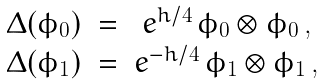Convert formula to latex. <formula><loc_0><loc_0><loc_500><loc_500>\begin{array} { c c c } \Delta ( \phi _ { 0 } ) & = & e ^ { h / 4 } \, \phi _ { 0 } \otimes \phi _ { 0 } \, , \\ \Delta ( \phi _ { 1 } ) & = & e ^ { - h / 4 } \, \phi _ { 1 } \otimes \phi _ { 1 } \, , \end{array}</formula> 